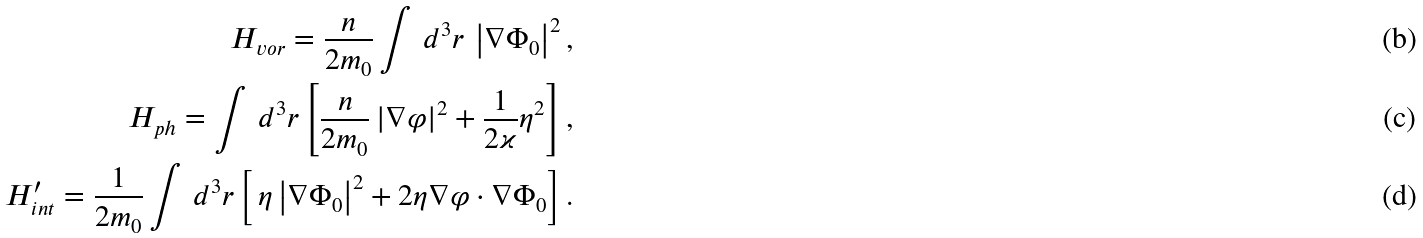<formula> <loc_0><loc_0><loc_500><loc_500>H _ { v o r } = \frac { n } { 2 m _ { 0 } } \int \, d ^ { 3 } r \, \left | \nabla \Phi _ { 0 } \right | ^ { 2 } , \\ H _ { p h } = \int \, d ^ { 3 } r \left [ \frac { n } { 2 m _ { 0 } } \left | \nabla \varphi \right | ^ { 2 } + \frac { 1 } { 2 \varkappa } \eta ^ { 2 } \right ] , \\ H ^ { \prime } _ { i n t } = \frac { 1 } { 2 m _ { 0 } } \int \, d ^ { 3 } r \left [ \, \eta \left | \nabla \Phi _ { 0 } \right | ^ { 2 } + 2 \eta \nabla \varphi \cdot \nabla \Phi _ { 0 } \right ] .</formula> 